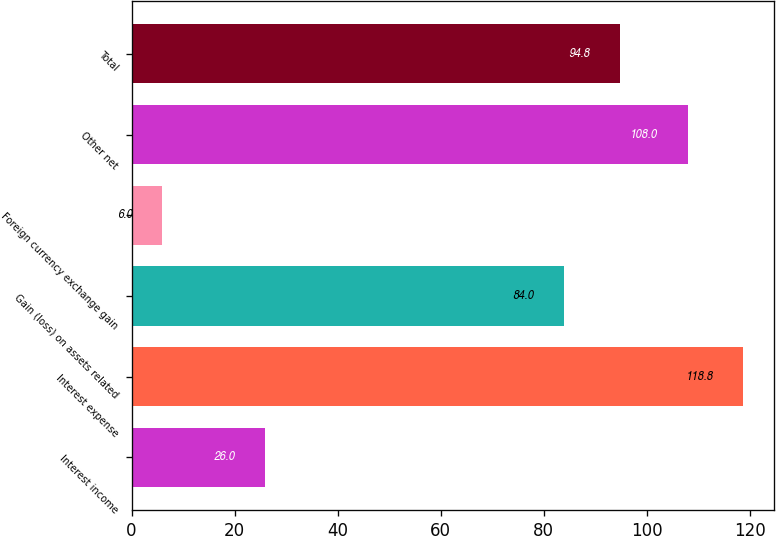<chart> <loc_0><loc_0><loc_500><loc_500><bar_chart><fcel>Interest income<fcel>Interest expense<fcel>Gain (loss) on assets related<fcel>Foreign currency exchange gain<fcel>Other net<fcel>Total<nl><fcel>26<fcel>118.8<fcel>84<fcel>6<fcel>108<fcel>94.8<nl></chart> 